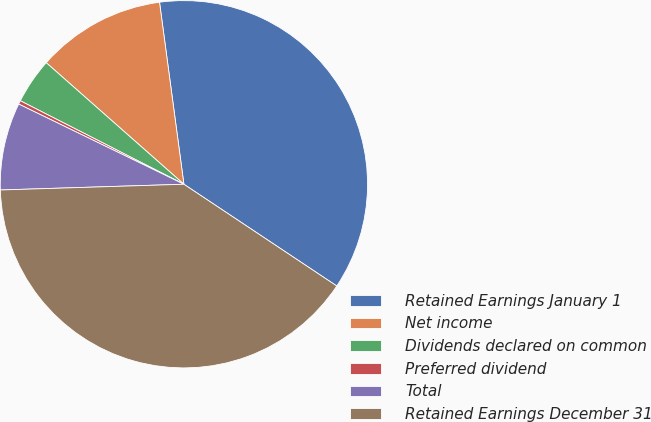<chart> <loc_0><loc_0><loc_500><loc_500><pie_chart><fcel>Retained Earnings January 1<fcel>Net income<fcel>Dividends declared on common<fcel>Preferred dividend<fcel>Total<fcel>Retained Earnings December 31<nl><fcel>36.47%<fcel>11.37%<fcel>4.0%<fcel>0.32%<fcel>7.69%<fcel>40.16%<nl></chart> 